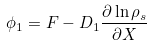<formula> <loc_0><loc_0><loc_500><loc_500>\phi _ { 1 } = F - D _ { 1 } \frac { \partial \ln \rho _ { s } } { \partial X }</formula> 